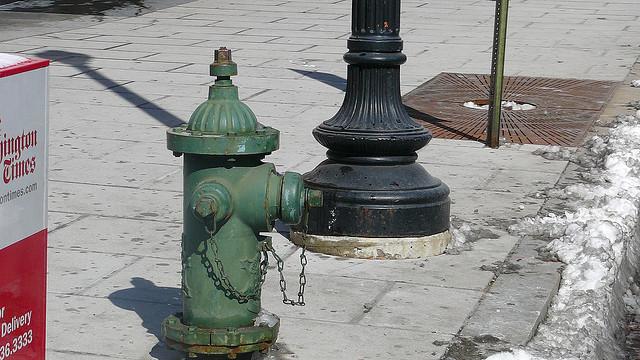What color is the fire hydrant?
Quick response, please. Green. What is cast?
Answer briefly. Fire hydrant. Where is the fire hydrant?
Give a very brief answer. Sidewalk. What color is the hydrant?
Keep it brief. Green. 